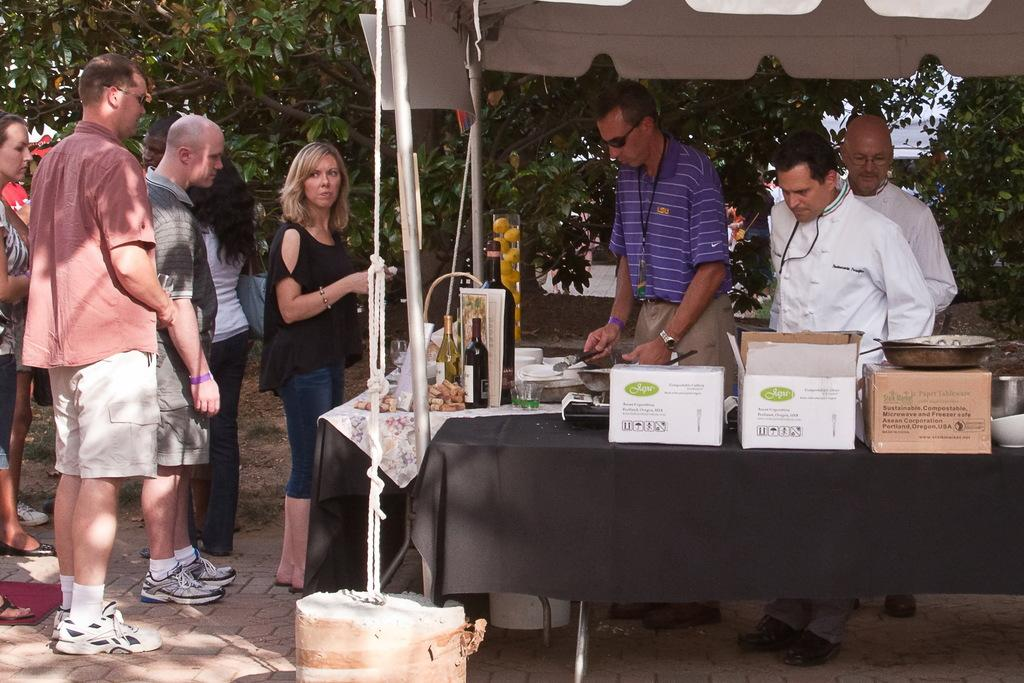What type of vegetation can be seen in the image? There are trees in the image. What else is present in the image besides the trees? There are people standing in the image, as well as a table. What items can be seen on the table? There are boxes, bottles, and bowls on the table. How many houses are visible in the image? There are no houses visible in the image. What type of yard can be seen in the image? There is no yard present in the image. 